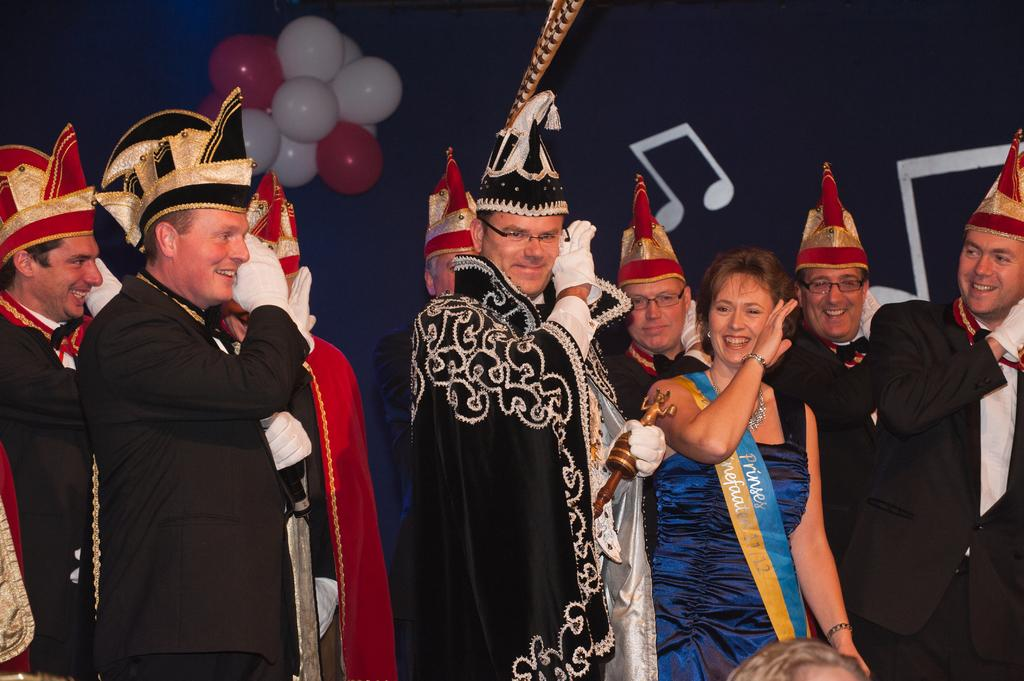Who is present in the image? There are persons in the image. What expression do the persons have? The persons are smiling. What can be seen in the background of the image? There are balloons in the background of the image. What type of prose is being recited by the persons in the image? There is no indication in the image that the persons are reciting any prose. How many boots can be seen on the persons in the image? There is no mention of boots in the image, so it cannot be determined how many boots are present. 